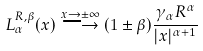Convert formula to latex. <formula><loc_0><loc_0><loc_500><loc_500>L ^ { R , \beta } _ { \alpha } ( x ) \stackrel { x \rightarrow \pm \infty } { \longrightarrow } ( 1 \pm \beta ) \frac { \gamma _ { \alpha } R ^ { \alpha } } { | x | ^ { \alpha + 1 } }</formula> 